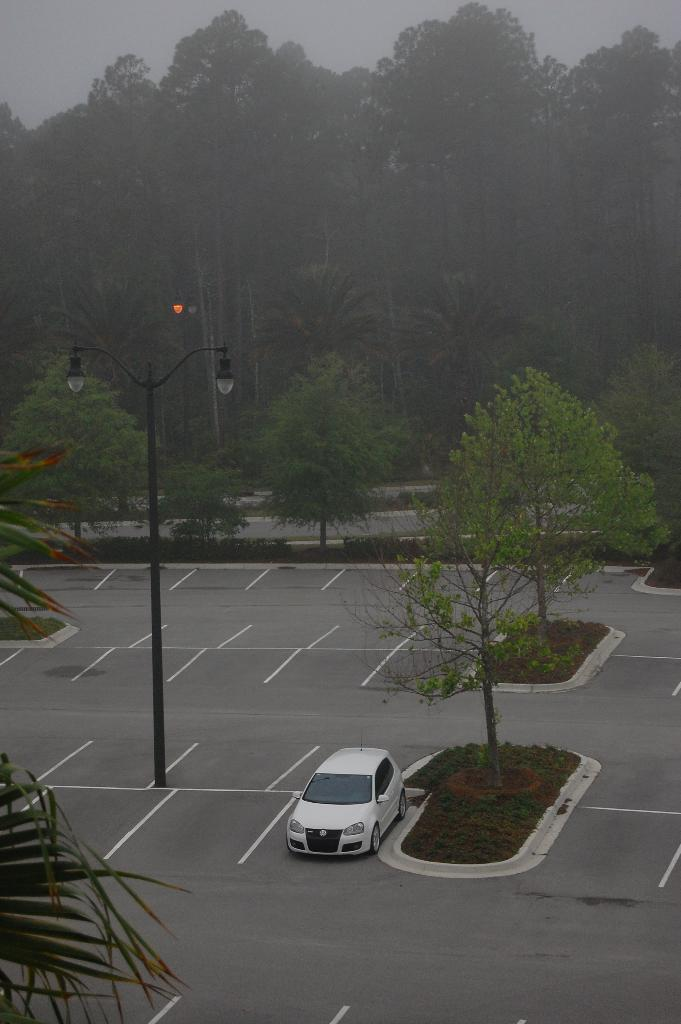What type of vegetation is visible in the image? There are trees in the image. What type of structures are present in the image? There are light-poles in the image. What type of vehicle can be seen on the road in the image? There is a white color car on the road in the image. Can you tell me how many basketballs are on the roof of the car in the image? There are no basketballs present in the image. Is there a tub visible in the image? There is no tub visible in the image. 